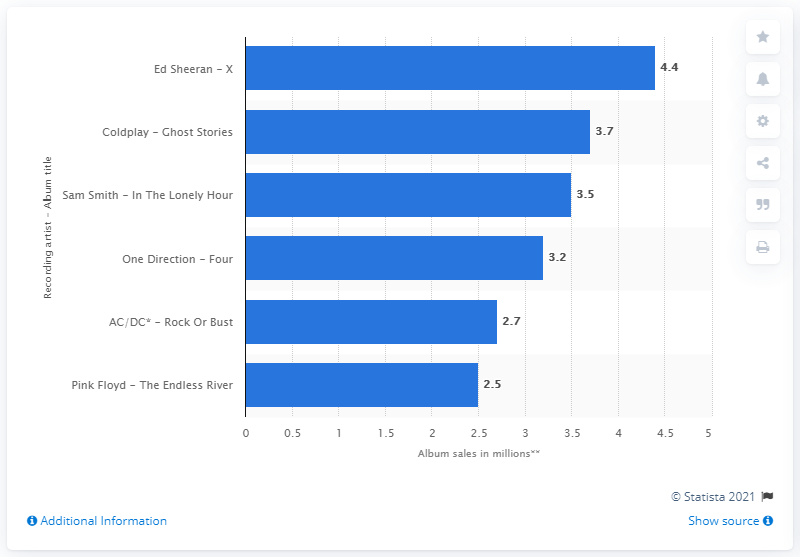Indicate a few pertinent items in this graphic. The global sales of Ed Sheeran's album X were 4.4 million. 